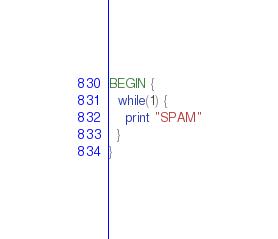Convert code to text. <code><loc_0><loc_0><loc_500><loc_500><_Awk_>BEGIN {
  while(1) {
    print "SPAM"
  }
}
</code> 